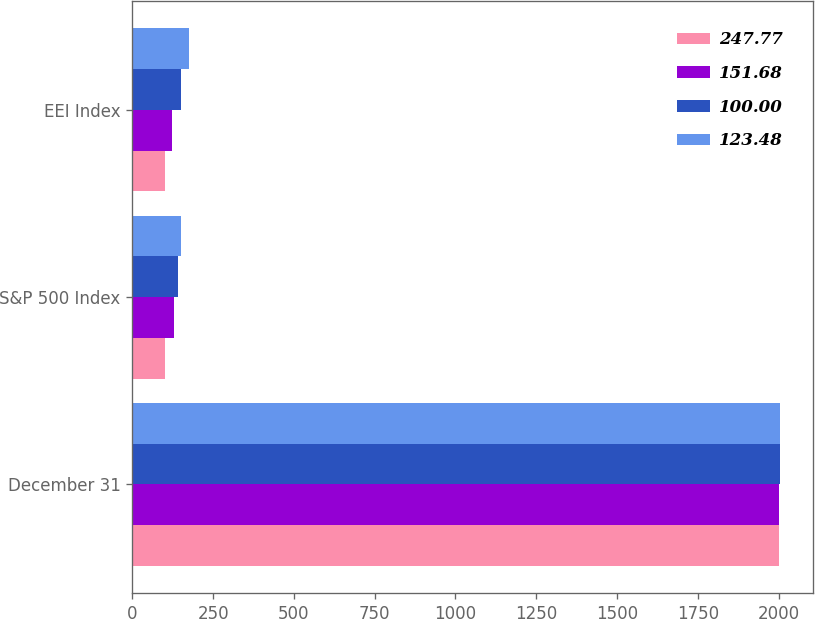Convert chart. <chart><loc_0><loc_0><loc_500><loc_500><stacked_bar_chart><ecel><fcel>December 31<fcel>S&P 500 Index<fcel>EEI Index<nl><fcel>247.77<fcel>2002<fcel>100<fcel>100<nl><fcel>151.68<fcel>2003<fcel>128.69<fcel>123.48<nl><fcel>100<fcel>2004<fcel>142.69<fcel>151.68<nl><fcel>123.48<fcel>2005<fcel>149.7<fcel>176.03<nl></chart> 